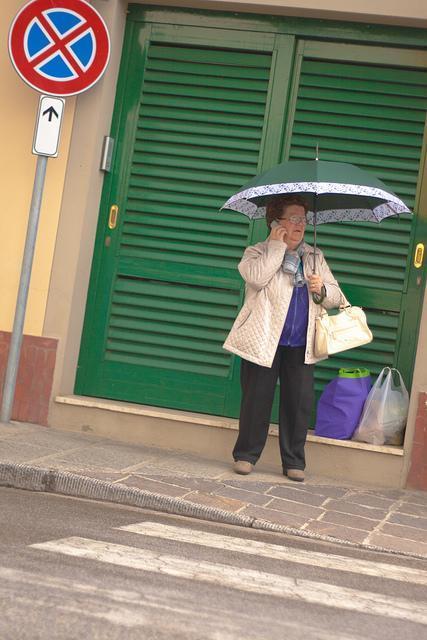How many handbags are in the photo?
Give a very brief answer. 2. How many buses are there?
Give a very brief answer. 0. 